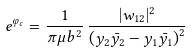Convert formula to latex. <formula><loc_0><loc_0><loc_500><loc_500>e ^ { \varphi _ { c } } = \frac { 1 } { \pi \mu b ^ { 2 } } \, \frac { | w _ { 1 2 } | ^ { 2 } } { { \left ( y _ { 2 } \bar { y _ { 2 } } - y _ { 1 } \bar { y _ { 1 } } \right ) } ^ { 2 } }</formula> 